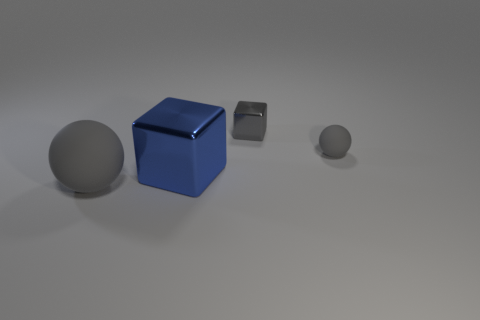There is a metallic object that is on the left side of the tiny gray block; what shape is it?
Give a very brief answer. Cube. What color is the small matte thing?
Give a very brief answer. Gray. There is a big blue thing that is the same material as the gray block; what shape is it?
Provide a succinct answer. Cube. There is a matte thing that is left of the blue object; does it have the same size as the big metallic cube?
Keep it short and to the point. Yes. What number of objects are either tiny things in front of the gray block or objects that are to the right of the gray metallic object?
Give a very brief answer. 1. Do the matte ball on the left side of the small block and the small matte sphere have the same color?
Your answer should be compact. Yes. What number of metal things are small blue balls or big objects?
Give a very brief answer. 1. What is the shape of the large gray thing?
Provide a short and direct response. Sphere. Does the big ball have the same material as the tiny gray block?
Keep it short and to the point. No. Are there any things behind the matte thing that is in front of the gray rubber thing behind the blue object?
Your answer should be very brief. Yes. 